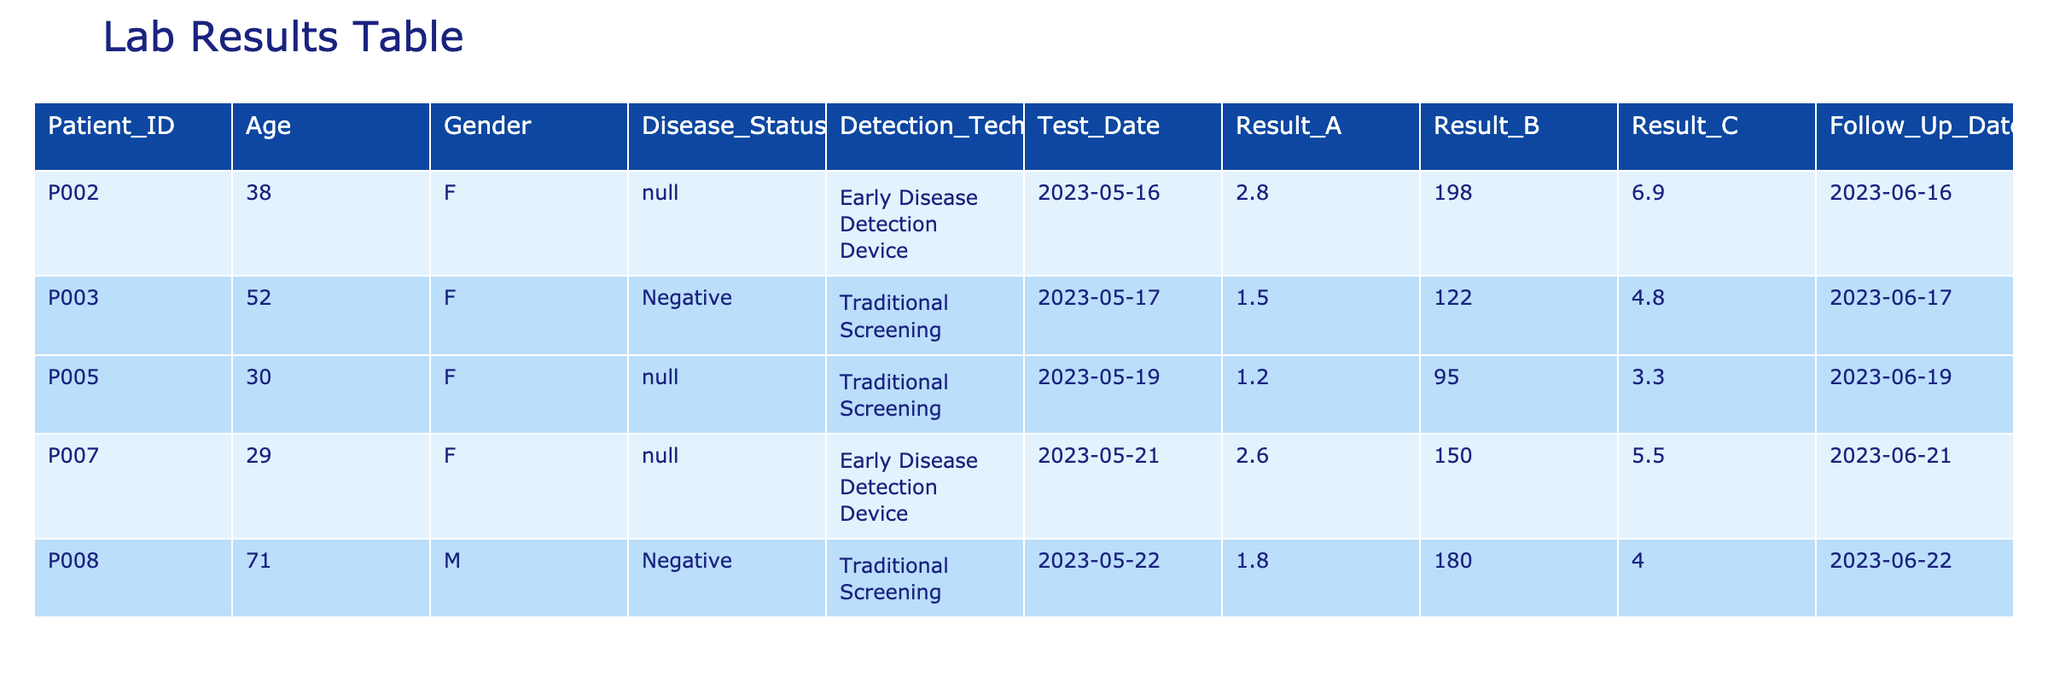What is the disease status of Patient P002? Referring to the table, Patient P002 has "N/A" listed under the Disease_Status column. Therefore, there is no specific disease status reported for this patient.
Answer: N/A What was the detection technology used for Patient P008? Looking at the table, Patient P008 utilized "Traditional Screening" as indicated in the Detection_Technology column.
Answer: Traditional Screening How many patients have their disease status classified as "Negative"? By reviewing the table, there are 2 patients (P003 and P008) with their Disease_Status marked as "Negative".
Answer: 2 What is the average Result_A for all patients using the Early Disease Detection Device? The patients using the Early Disease Detection Device are P002 and P007. Their Result_A values are 2.8 and 2.6 respectively. The average is calculated as (2.8 + 2.6) / 2 = 2.7.
Answer: 2.7 Did all patients that used "Early Disease Detection Device" have a follow-up date after their test date? Referring to the follow-up dates, both patients P002 and P007 have their Follow_Up_Date listed after their respective Test_Date (both have June dates following May dates). Therefore, it is true that all had follow-ups after their tests.
Answer: Yes What is the difference between the highest Result_B and the lowest Result_B in the table? Analyzing the Result_B values, the highest is 198 (Patient P002) and the lowest is 95 (Patient P005). The difference is calculated as 198 - 95 = 103.
Answer: 103 What is the total number of male patients in the table? Looking at the Gender column, there is only 1 male patient (P008), making the total male patients equal to 1.
Answer: 1 Which patient had the highest Result_C, and what was that value? Reviewing the Result_C values, Patient P002 has the highest Result_C at 6.9, compared to other values in the column.
Answer: P002, 6.9 What is the average age of patients using Traditional Screening? The patients using Traditional Screening are P003, P005, and P008 with ages 52, 30, and 71 respectively. The average age is calculated by (52 + 30 + 71) / 3 = 51.
Answer: 51 